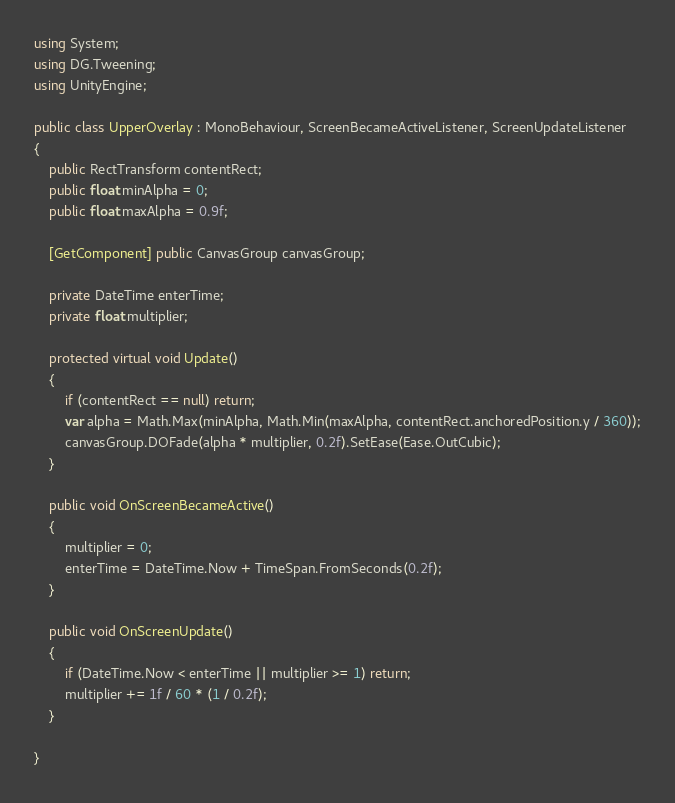Convert code to text. <code><loc_0><loc_0><loc_500><loc_500><_C#_>using System;
using DG.Tweening;
using UnityEngine;

public class UpperOverlay : MonoBehaviour, ScreenBecameActiveListener, ScreenUpdateListener
{
    public RectTransform contentRect;
    public float minAlpha = 0;
    public float maxAlpha = 0.9f;
    
    [GetComponent] public CanvasGroup canvasGroup;

    private DateTime enterTime;
    private float multiplier;

    protected virtual void Update()
    {
        if (contentRect == null) return;
        var alpha = Math.Max(minAlpha, Math.Min(maxAlpha, contentRect.anchoredPosition.y / 360));
        canvasGroup.DOFade(alpha * multiplier, 0.2f).SetEase(Ease.OutCubic);
    }

    public void OnScreenBecameActive()
    {
        multiplier = 0;
        enterTime = DateTime.Now + TimeSpan.FromSeconds(0.2f);
    }

    public void OnScreenUpdate()
    {
        if (DateTime.Now < enterTime || multiplier >= 1) return;
        multiplier += 1f / 60 * (1 / 0.2f);
    }
    
}</code> 